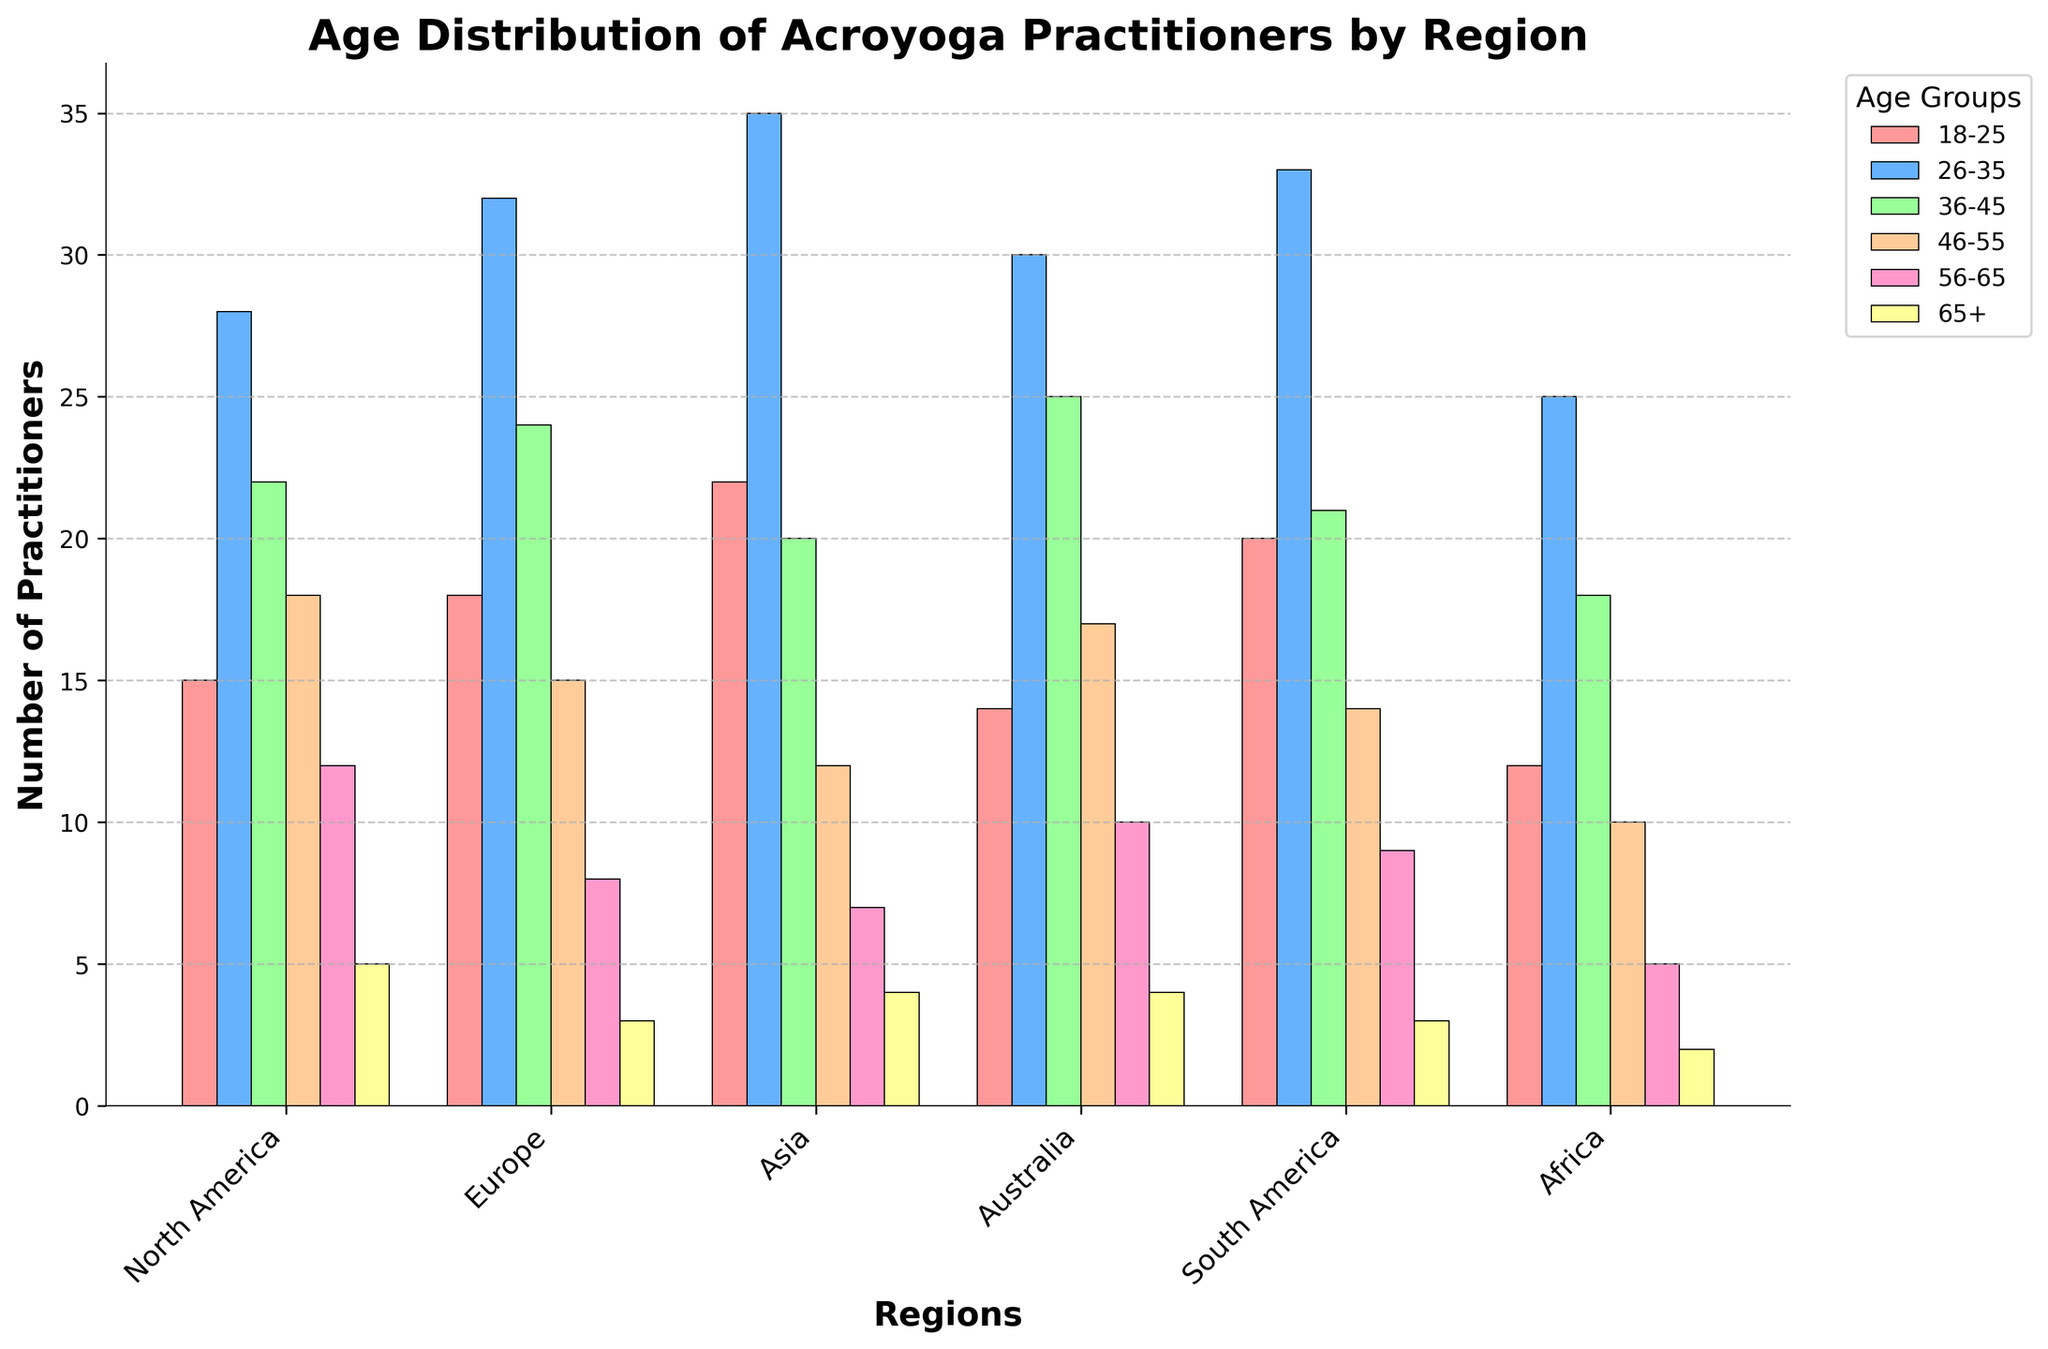Which region has the largest number of acroyoga practitioners in the 26-35 age group? By visually checking the height of the bars in the 26-35 age group (blue), Europe has the tallest bar. Thus, Europe has the largest number of acroyoga practitioners in this age group.
Answer: Europe In which region do the 18-25 age group practitioners exceed 20? By checking the height of the red bars for each region and their corresponding values, we see that Asia (22) and South America (20) have bars exceeding or equal to 20.
Answer: Asia, South America How many total practitioners are there in North America across all age groups? Summing the values for North America across all age groups: 15 (18-25) + 28 (26-35) + 22 (36-45) + 18 (46-55) + 12 (56-65) + 5 (65+). The total is 100.
Answer: 100 What is the average number of practitioners in the 36-45 age group across all regions? Summing up the values for the 36-45 age group from all regions: 22 (North America) + 24 (Europe) + 20 (Asia) + 25 (Australia) + 21 (South America) + 18 (Africa). The total is 130. The average is 130/6 = 21.67.
Answer: 21.67 Is the number of practitioners aged 65+ higher in North America or Europe? By visually comparing the height of the bars for the 65+ age group (yellow) in North America (5) and Europe (3), North America is higher.
Answer: North America Which region has the least number of practitioners in the 56-65 age group? By visually checking the height of the orange bars for the 56-65 age group, Africa has the smallest bar with a value of 5.
Answer: Africa Compare the total number of practitioners in Asia and Australia. Which region has more, and by how much? Summing the values for each age group in Asia and Australia: Asia (22 + 35 + 20 + 12 + 7 + 4 = 100), Australia (14 + 30 + 25 + 17 + 10 + 4 = 100). Both regions have the same amount.
Answer: Same, 0 What is the combined total of practitioners aged 36-45 and 46-55 in South America? Summing the values for the 36-45 and 46-55 age groups in South America: 21 (36-45) + 14 (46-55). The total is 35.
Answer: 35 Is there any age group in a region where the practitioners exceed 30? If yes, specify the age group and region. By visually checking the bars, the 26-35 age group in Europe (32), Asia (35), and South America (33) exceeds 30 practitioners.
Answer: Europe (26-35), Asia (26-35), South America (26-35) Which region has the smallest variation in the number of practitioners between the 18-25 and 26-35 age groups? By comparing the difference between the 18-25 and 26-35 age groups for each region, Africa (25-12=13) has the smallest variation.
Answer: Africa 